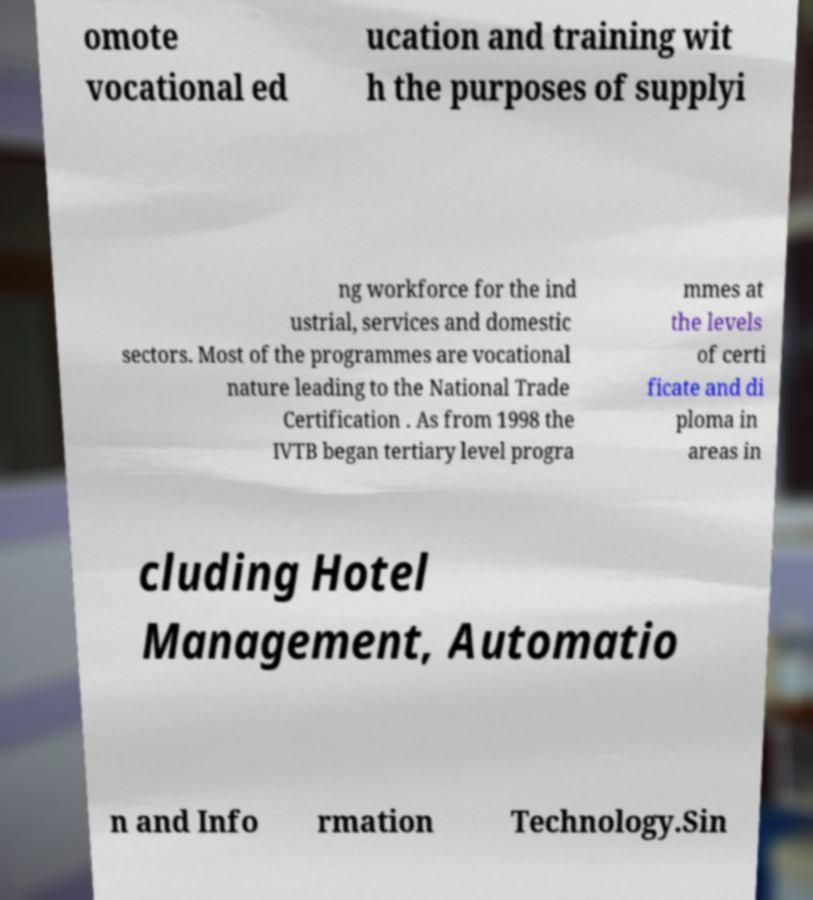Please read and relay the text visible in this image. What does it say? omote vocational ed ucation and training wit h the purposes of supplyi ng workforce for the ind ustrial, services and domestic sectors. Most of the programmes are vocational nature leading to the National Trade Certification . As from 1998 the IVTB began tertiary level progra mmes at the levels of certi ficate and di ploma in areas in cluding Hotel Management, Automatio n and Info rmation Technology.Sin 